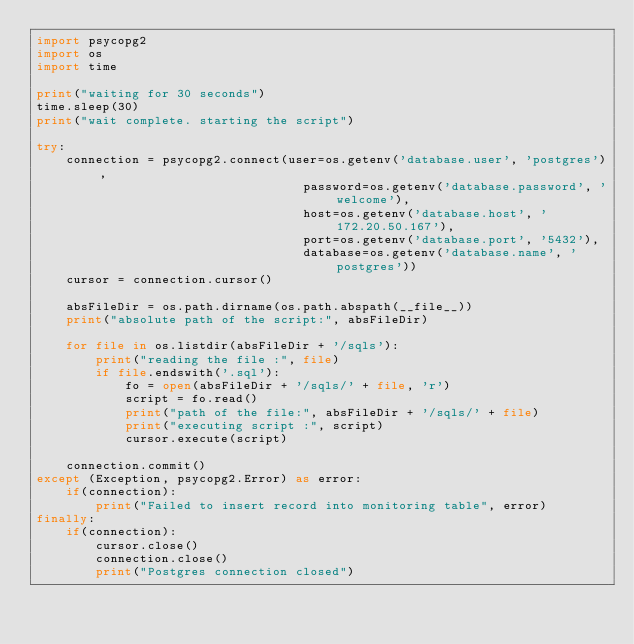Convert code to text. <code><loc_0><loc_0><loc_500><loc_500><_Python_>import psycopg2
import os
import time

print("waiting for 30 seconds")
time.sleep(30)
print("wait complete. starting the script")

try:
    connection = psycopg2.connect(user=os.getenv('database.user', 'postgres'),
                                    password=os.getenv('database.password', 'welcome'),
                                    host=os.getenv('database.host', '172.20.50.167'),
                                    port=os.getenv('database.port', '5432'),
                                    database=os.getenv('database.name', 'postgres'))
    cursor = connection.cursor()

    absFileDir = os.path.dirname(os.path.abspath(__file__))
    print("absolute path of the script:", absFileDir)

    for file in os.listdir(absFileDir + '/sqls'):
        print("reading the file :", file)
        if file.endswith('.sql'):
            fo = open(absFileDir + '/sqls/' + file, 'r')
            script = fo.read()
            print("path of the file:", absFileDir + '/sqls/' + file)
            print("executing script :", script)
            cursor.execute(script)

    connection.commit()
except (Exception, psycopg2.Error) as error:
    if(connection):
        print("Failed to insert record into monitoring table", error)
finally:
    if(connection):
        cursor.close()
        connection.close()
        print("Postgres connection closed")
</code> 